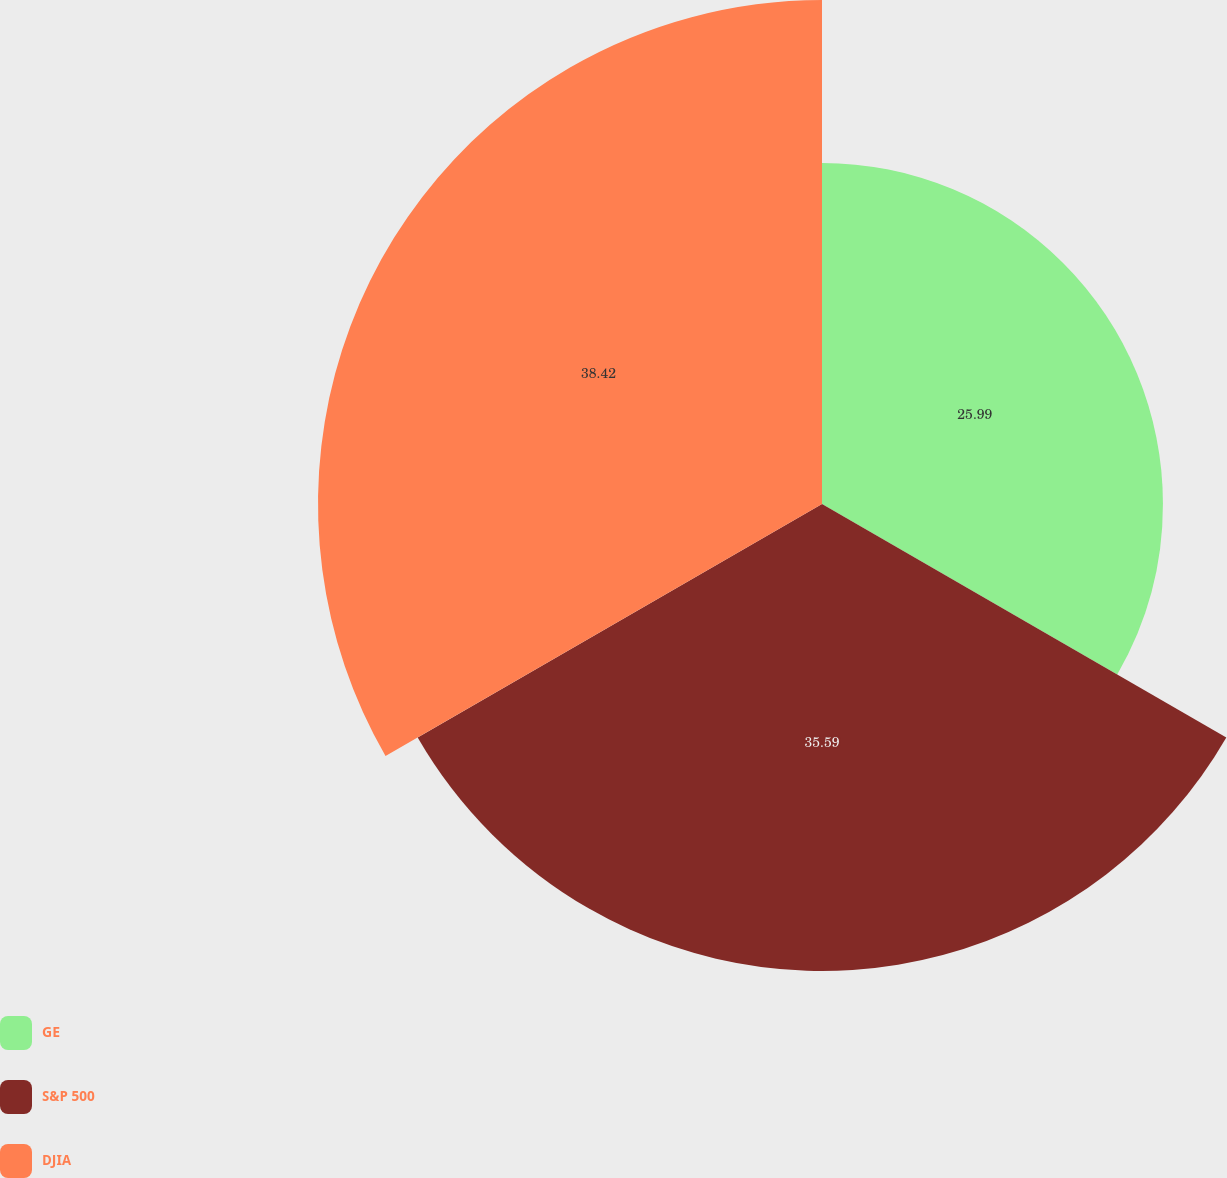<chart> <loc_0><loc_0><loc_500><loc_500><pie_chart><fcel>GE<fcel>S&P 500<fcel>DJIA<nl><fcel>25.99%<fcel>35.59%<fcel>38.42%<nl></chart> 